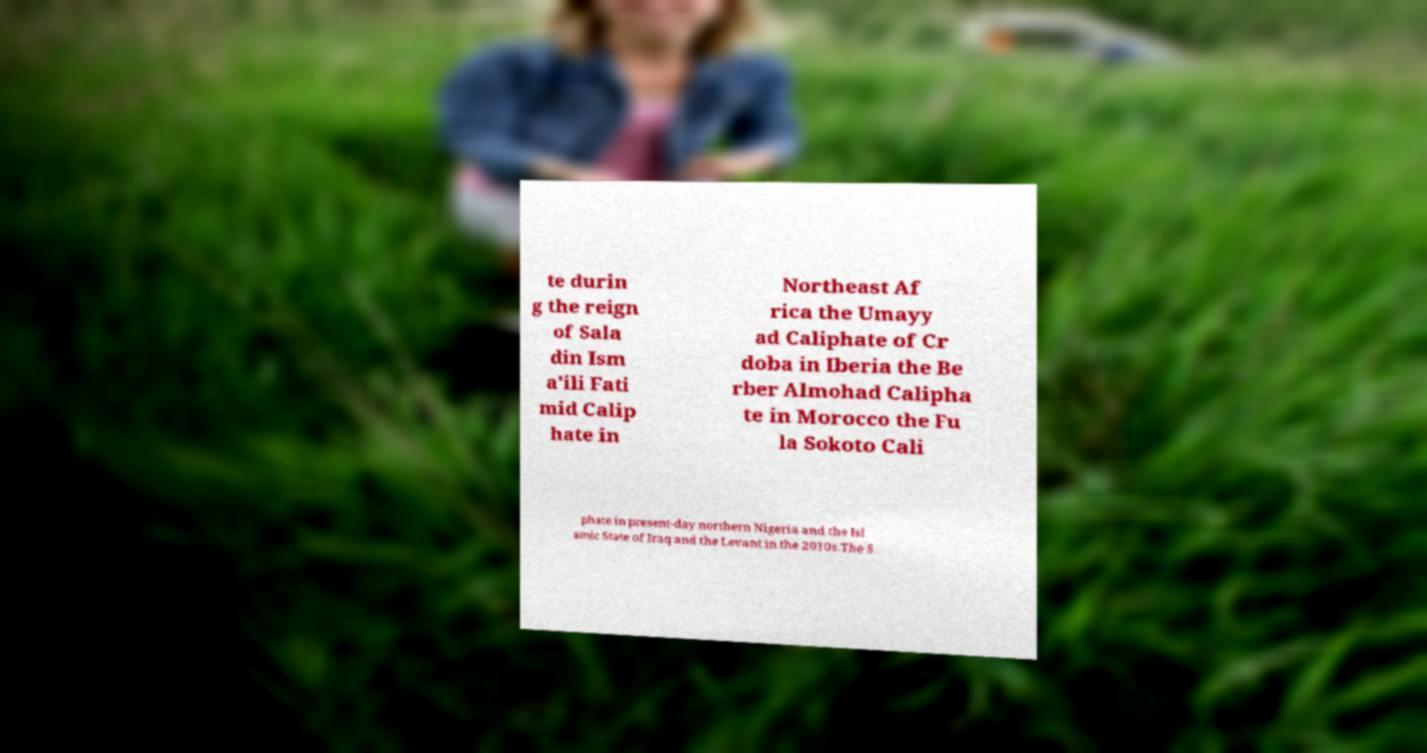What messages or text are displayed in this image? I need them in a readable, typed format. te durin g the reign of Sala din Ism a'ili Fati mid Calip hate in Northeast Af rica the Umayy ad Caliphate of Cr doba in Iberia the Be rber Almohad Calipha te in Morocco the Fu la Sokoto Cali phate in present-day northern Nigeria and the Isl amic State of Iraq and the Levant in the 2010s.The S 